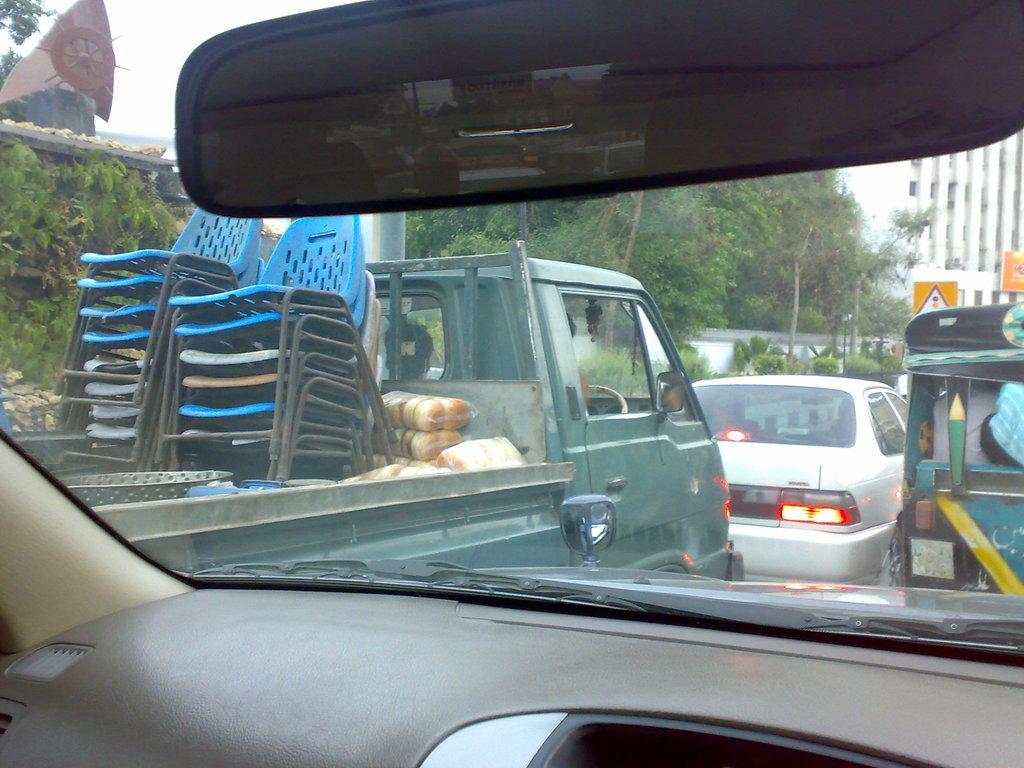Please provide a concise description of this image. In this image we can see a vehicle with the mirror and also the glass and through the glass we can see the other vehicles, trees, plants, building, wall, sign board, banner, chairs and also the food items. We can also see the sky. 